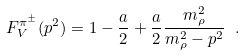<formula> <loc_0><loc_0><loc_500><loc_500>F _ { V } ^ { \pi ^ { \pm } } ( p ^ { 2 } ) = 1 - \frac { a } { 2 } + \frac { a } { 2 } \frac { m _ { \rho } ^ { 2 } } { m _ { \rho } ^ { 2 } - p ^ { 2 } } \ .</formula> 